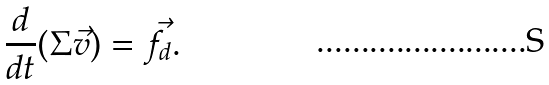Convert formula to latex. <formula><loc_0><loc_0><loc_500><loc_500>\frac { d } { d t } ( \Sigma \vec { v } ) = \vec { f } _ { d } .</formula> 